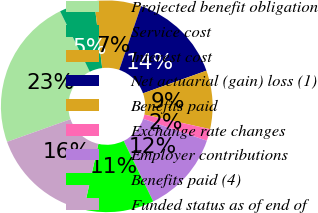<chart> <loc_0><loc_0><loc_500><loc_500><pie_chart><fcel>Projected benefit obligation<fcel>Service cost<fcel>Interest cost<fcel>Net actuarial (gain) loss (1)<fcel>Benefits paid<fcel>Exchange rate changes<fcel>Employer contributions<fcel>Benefits paid (4)<fcel>Funded status as of end of<nl><fcel>23.19%<fcel>5.37%<fcel>7.15%<fcel>14.28%<fcel>8.93%<fcel>1.81%<fcel>12.5%<fcel>10.72%<fcel>16.06%<nl></chart> 